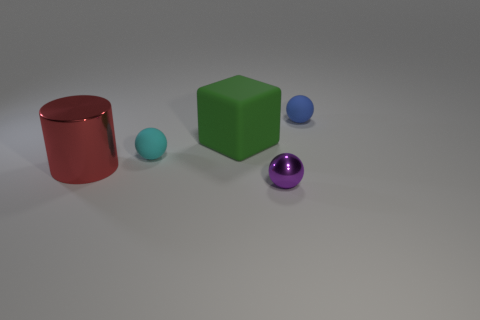There is a matte ball on the right side of the big object behind the red object; what is its color?
Your response must be concise. Blue. There is a thing in front of the large red cylinder in front of the small cyan sphere; is there a ball right of it?
Give a very brief answer. Yes. What is the color of the small sphere that is the same material as the big red thing?
Your answer should be very brief. Purple. What number of large blocks are made of the same material as the small cyan object?
Make the answer very short. 1. Do the big cylinder and the big thing behind the cylinder have the same material?
Offer a terse response. No. What number of things are either tiny rubber things in front of the big green matte block or gray cylinders?
Provide a short and direct response. 1. There is a rubber sphere left of the small matte ball that is on the right side of the object that is in front of the large red metal object; what size is it?
Offer a terse response. Small. Are there any other things that have the same shape as the large red metal thing?
Provide a succinct answer. No. How big is the metallic object that is to the left of the small sphere to the left of the purple sphere?
Ensure brevity in your answer.  Large. What number of small objects are either cyan metallic spheres or matte cubes?
Your response must be concise. 0. 